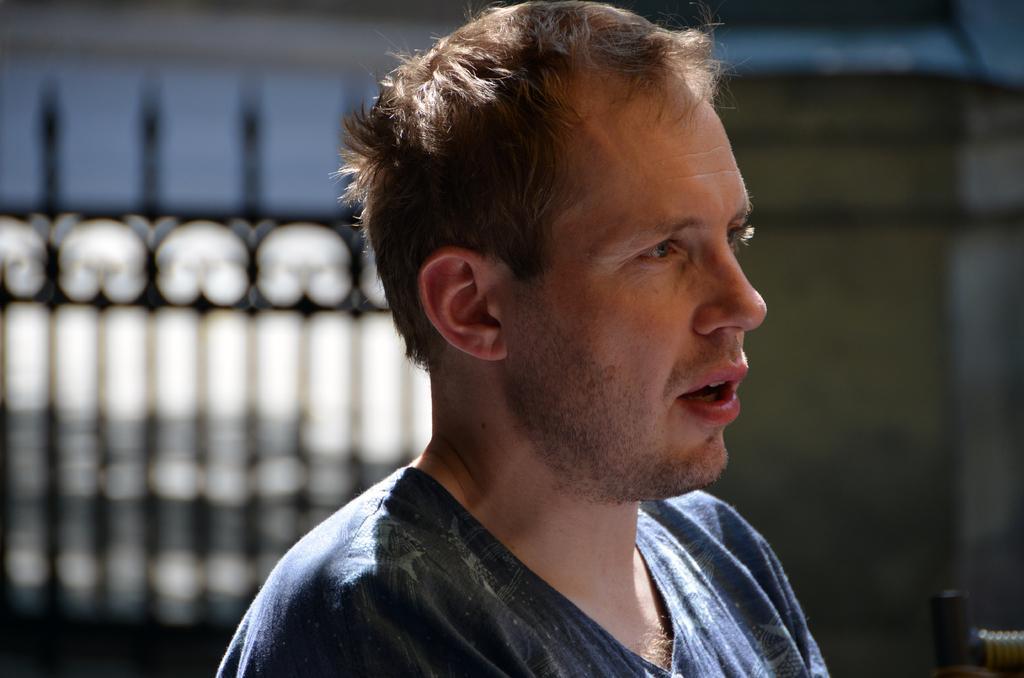Describe this image in one or two sentences. In this picture there is a person with blue t-shirt. At the back there is a railing and there is a wall. 